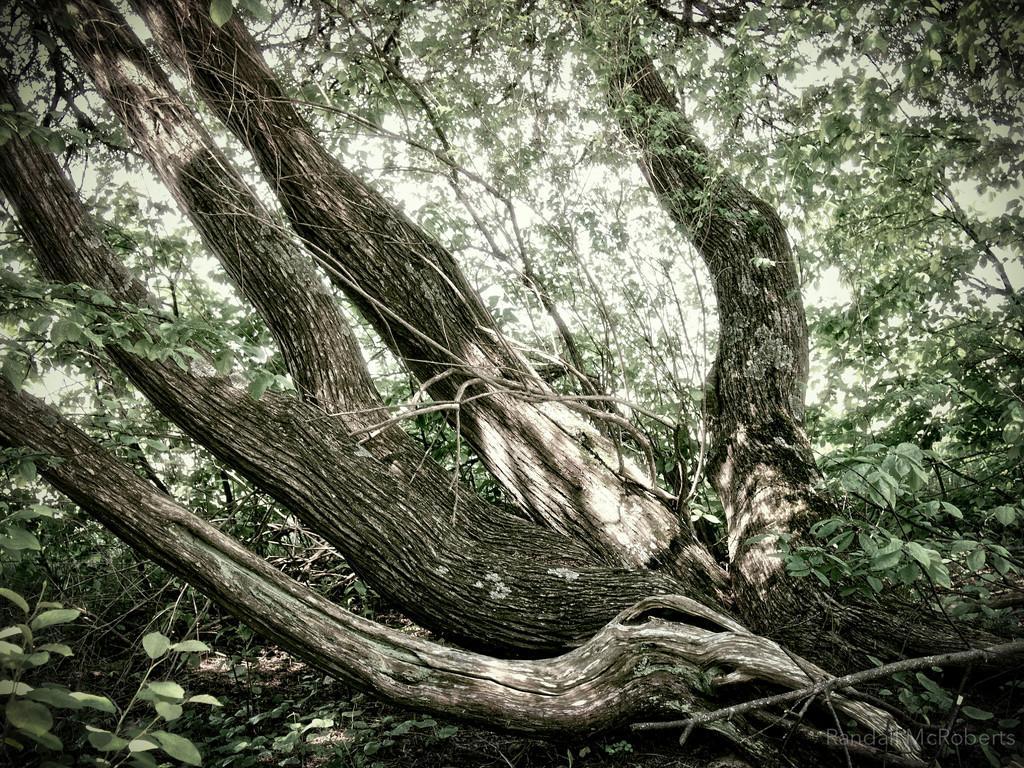Describe this image in one or two sentences. In this image I can see few tree and tree trunks. The sky is in white color. 